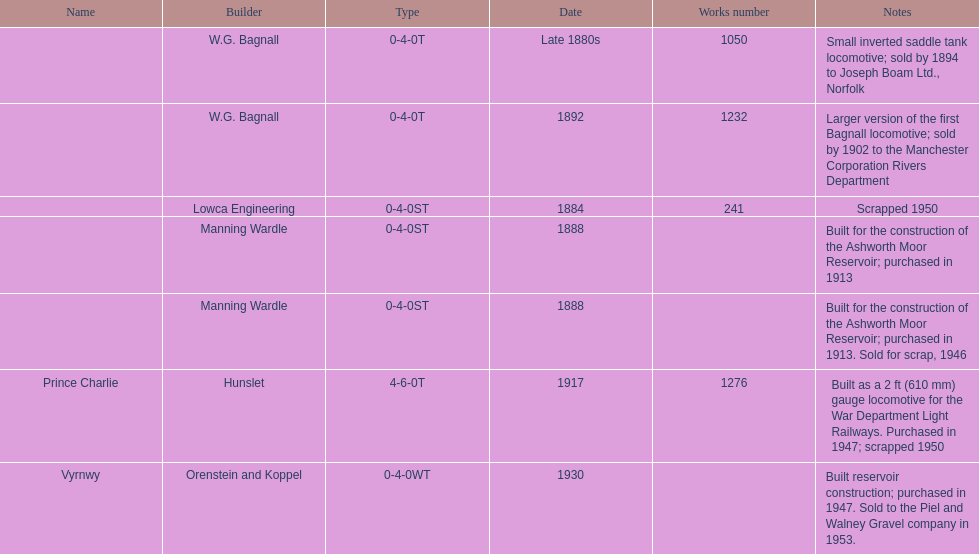What was the last locomotive? Vyrnwy. 